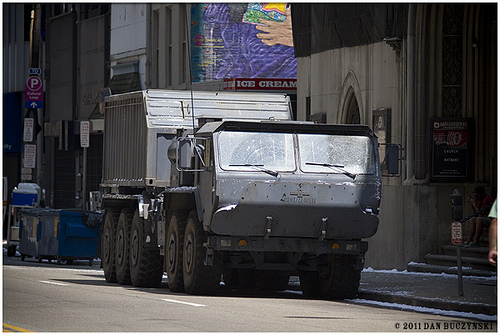<image>
Is the ice cream on the building? Yes. Looking at the image, I can see the ice cream is positioned on top of the building, with the building providing support. 